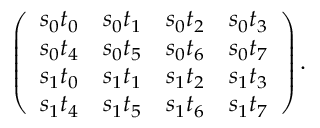Convert formula to latex. <formula><loc_0><loc_0><loc_500><loc_500>\left ( \begin{array} { l l l l } { s _ { 0 } t _ { 0 } } & { s _ { 0 } t _ { 1 } } & { s _ { 0 } t _ { 2 } } & { s _ { 0 } t _ { 3 } } \\ { s _ { 0 } t _ { 4 } } & { s _ { 0 } t _ { 5 } } & { s _ { 0 } t _ { 6 } } & { s _ { 0 } t _ { 7 } } \\ { s _ { 1 } t _ { 0 } } & { s _ { 1 } t _ { 1 } } & { s _ { 1 } t _ { 2 } } & { s _ { 1 } t _ { 3 } } \\ { s _ { 1 } t _ { 4 } } & { s _ { 1 } t _ { 5 } } & { s _ { 1 } t _ { 6 } } & { s _ { 1 } t _ { 7 } } \end{array} \right ) .</formula> 